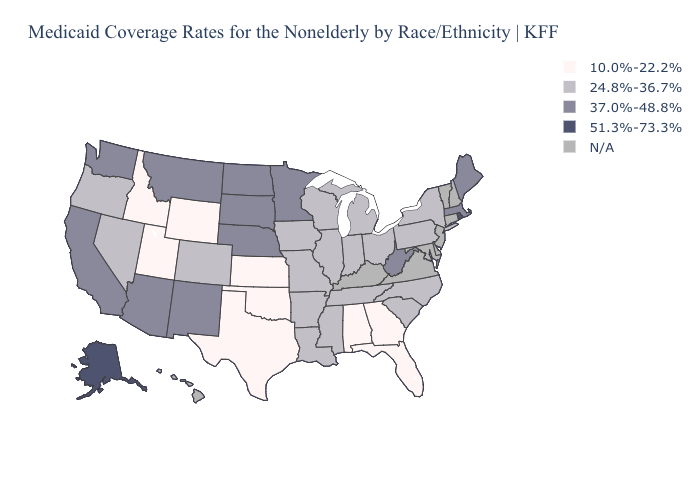Does Montana have the lowest value in the USA?
Concise answer only. No. What is the value of Michigan?
Short answer required. 24.8%-36.7%. Name the states that have a value in the range 37.0%-48.8%?
Quick response, please. Arizona, California, Maine, Massachusetts, Minnesota, Montana, Nebraska, New Mexico, North Dakota, South Dakota, Washington, West Virginia. Among the states that border South Dakota , does Montana have the highest value?
Quick response, please. Yes. What is the lowest value in the MidWest?
Quick response, please. 10.0%-22.2%. Name the states that have a value in the range 10.0%-22.2%?
Write a very short answer. Alabama, Florida, Georgia, Idaho, Kansas, Oklahoma, Texas, Utah, Wyoming. Which states have the lowest value in the USA?
Write a very short answer. Alabama, Florida, Georgia, Idaho, Kansas, Oklahoma, Texas, Utah, Wyoming. Does Ohio have the highest value in the USA?
Be succinct. No. What is the value of Utah?
Concise answer only. 10.0%-22.2%. Does the first symbol in the legend represent the smallest category?
Concise answer only. Yes. Name the states that have a value in the range 51.3%-73.3%?
Answer briefly. Alaska, Rhode Island. What is the value of Indiana?
Concise answer only. 24.8%-36.7%. What is the highest value in states that border Florida?
Short answer required. 10.0%-22.2%. What is the value of South Dakota?
Keep it brief. 37.0%-48.8%. Is the legend a continuous bar?
Answer briefly. No. 